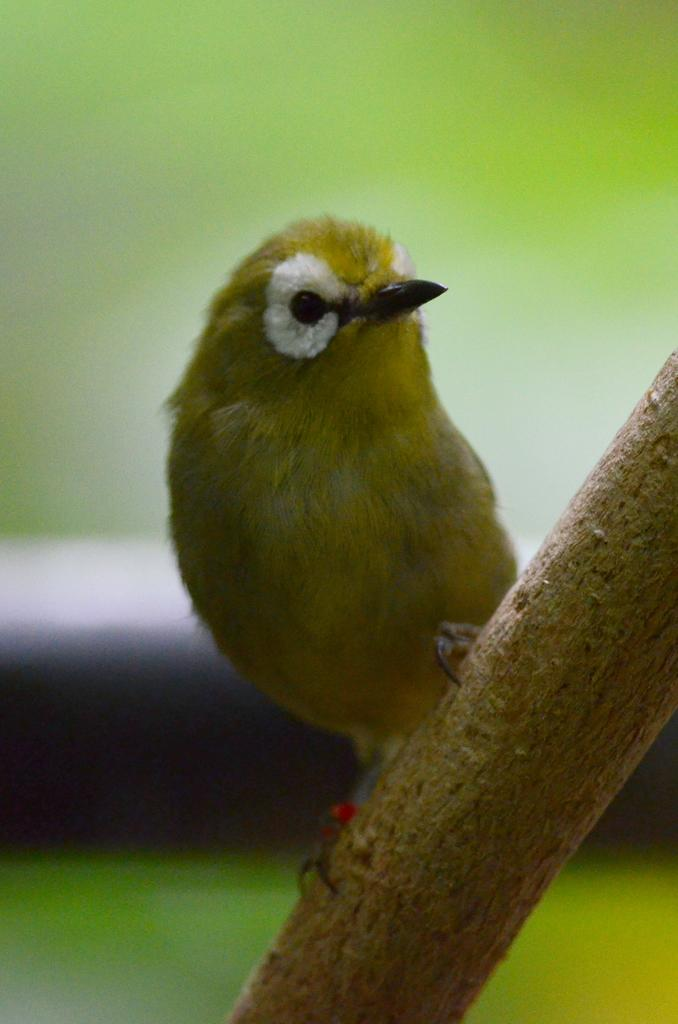What type of animal can be seen in the image? There is a bird in the image. Can you describe the background of the image? The background of the image is blurred. What type of ring is the bird wearing on its leg in the image? There is no ring visible on the bird's leg in the image. What type of farming equipment can be seen in the image? There is no farming equipment present in the image; it features a bird and a blurred background. 